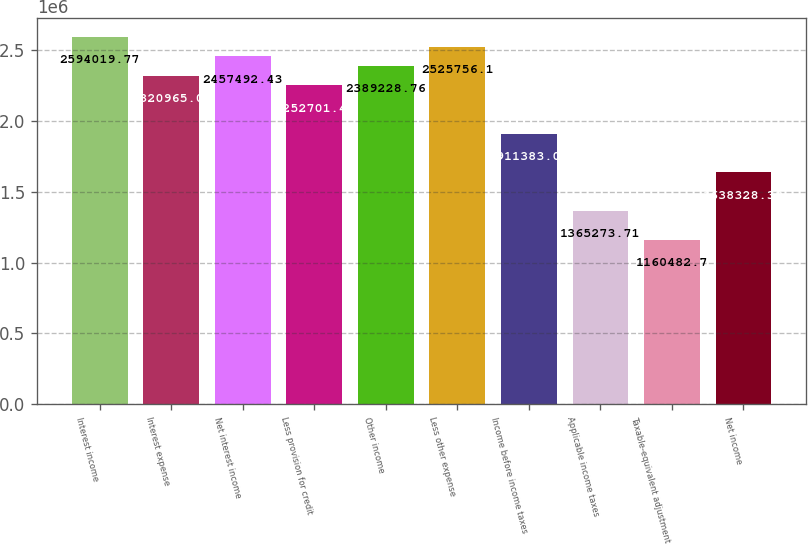Convert chart to OTSL. <chart><loc_0><loc_0><loc_500><loc_500><bar_chart><fcel>Interest income<fcel>Interest expense<fcel>Net interest income<fcel>Less provision for credit<fcel>Other income<fcel>Less other expense<fcel>Income before income taxes<fcel>Applicable income taxes<fcel>Taxable-equivalent adjustment<fcel>Net income<nl><fcel>2.59402e+06<fcel>2.32097e+06<fcel>2.45749e+06<fcel>2.2527e+06<fcel>2.38923e+06<fcel>2.52576e+06<fcel>1.91138e+06<fcel>1.36527e+06<fcel>1.16048e+06<fcel>1.63833e+06<nl></chart> 